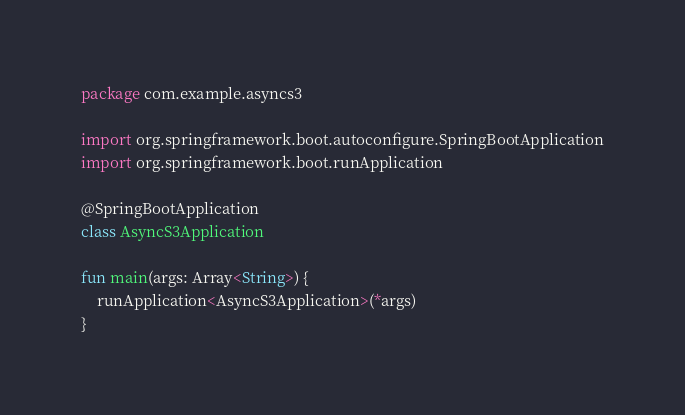Convert code to text. <code><loc_0><loc_0><loc_500><loc_500><_Kotlin_>package com.example.asyncs3

import org.springframework.boot.autoconfigure.SpringBootApplication
import org.springframework.boot.runApplication

@SpringBootApplication
class AsyncS3Application

fun main(args: Array<String>) {
    runApplication<AsyncS3Application>(*args)
}
</code> 